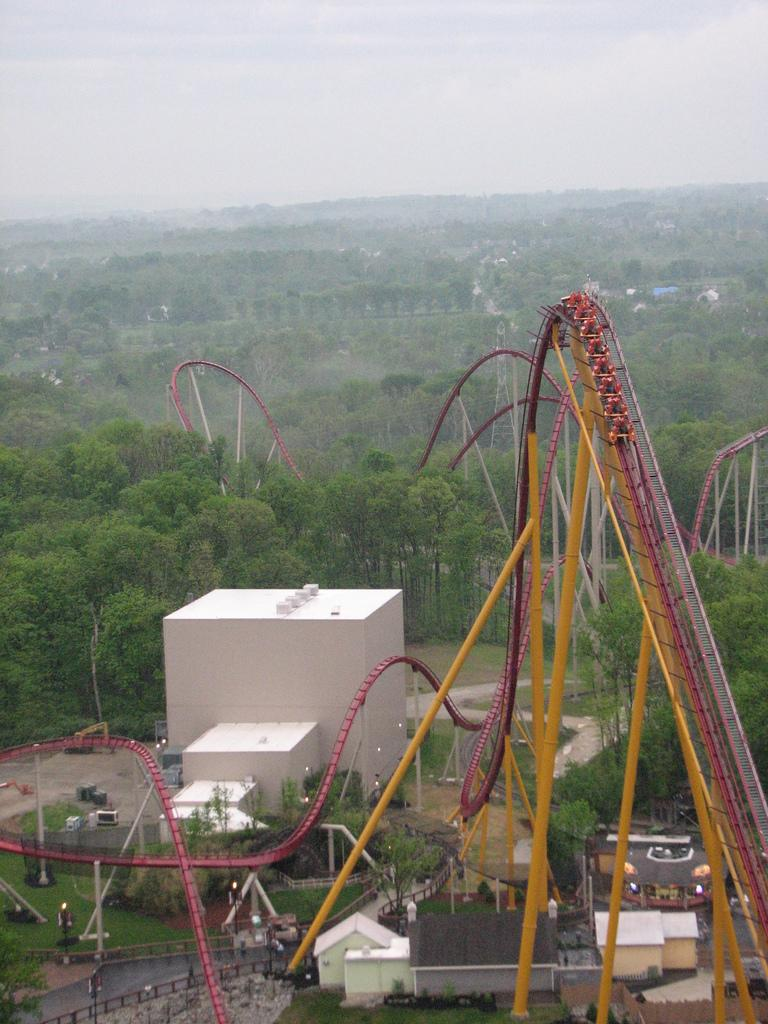What is the main attraction in the image? There is a roller coaster in the image. What else can be seen in the image besides the roller coaster? There are buildings, trees, poles, and other objects on the ground in the image. What is visible in the background of the image? The sky is visible in the background of the image. What type of cord is hanging from the roller coaster in the image? There is no cord hanging from the roller coaster in the image. Can you see a swing in the image? There is no swing present in the image. 